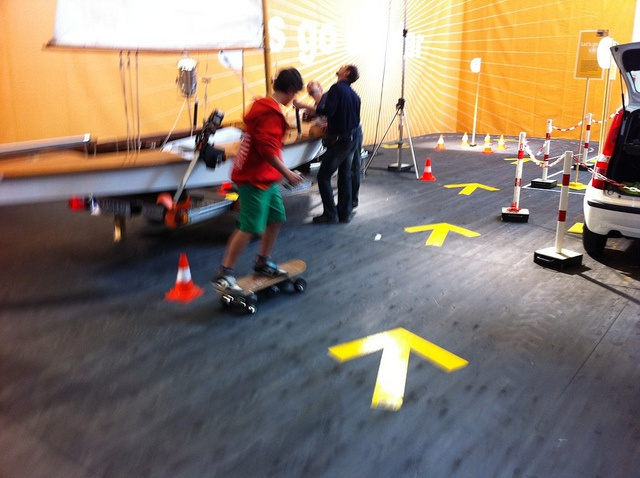Describe the objects in this image and their specific colors. I can see people in orange, black, maroon, brown, and teal tones, car in orange, black, darkgray, gray, and white tones, people in orange, black, navy, gray, and maroon tones, skateboard in orange, black, and gray tones, and people in orange, black, navy, brown, and lightpink tones in this image. 